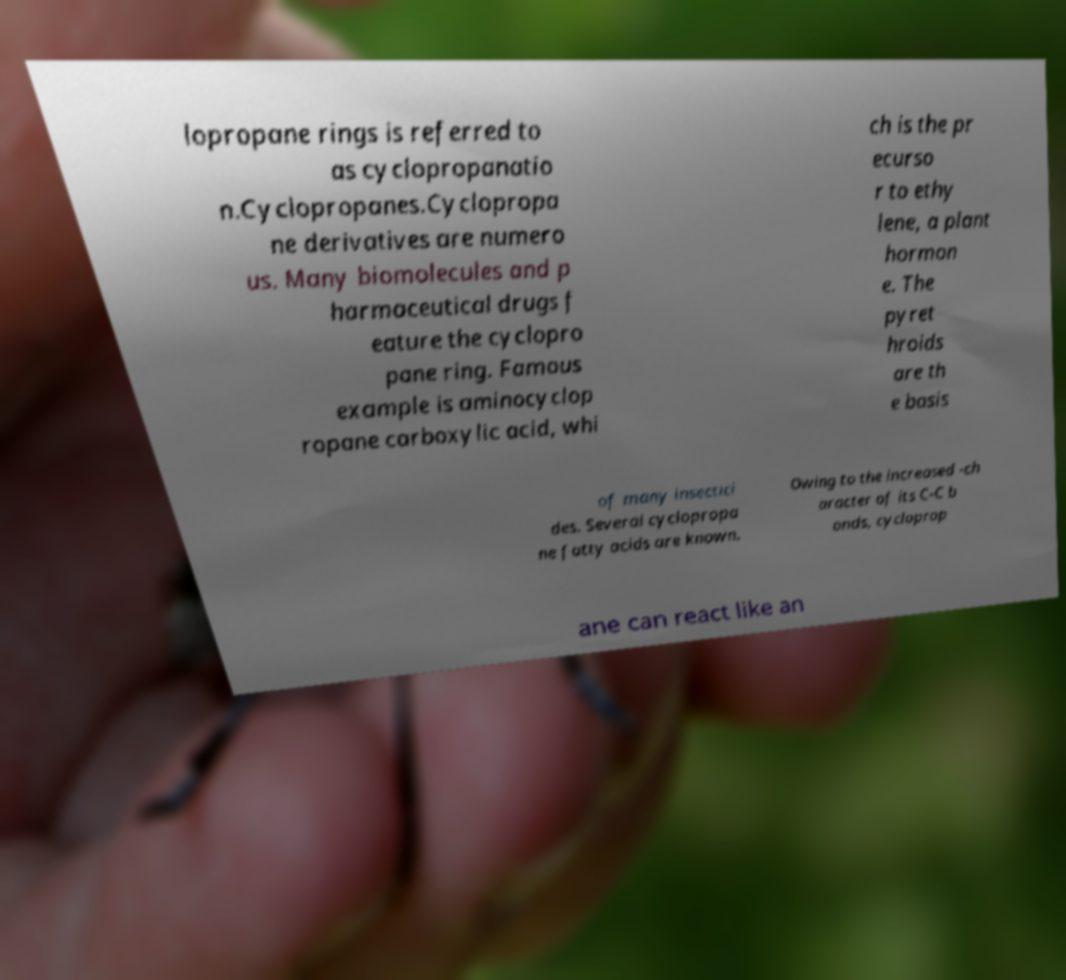Can you accurately transcribe the text from the provided image for me? lopropane rings is referred to as cyclopropanatio n.Cyclopropanes.Cyclopropa ne derivatives are numero us. Many biomolecules and p harmaceutical drugs f eature the cyclopro pane ring. Famous example is aminocyclop ropane carboxylic acid, whi ch is the pr ecurso r to ethy lene, a plant hormon e. The pyret hroids are th e basis of many insectici des. Several cyclopropa ne fatty acids are known. Owing to the increased -ch aracter of its C-C b onds, cycloprop ane can react like an 